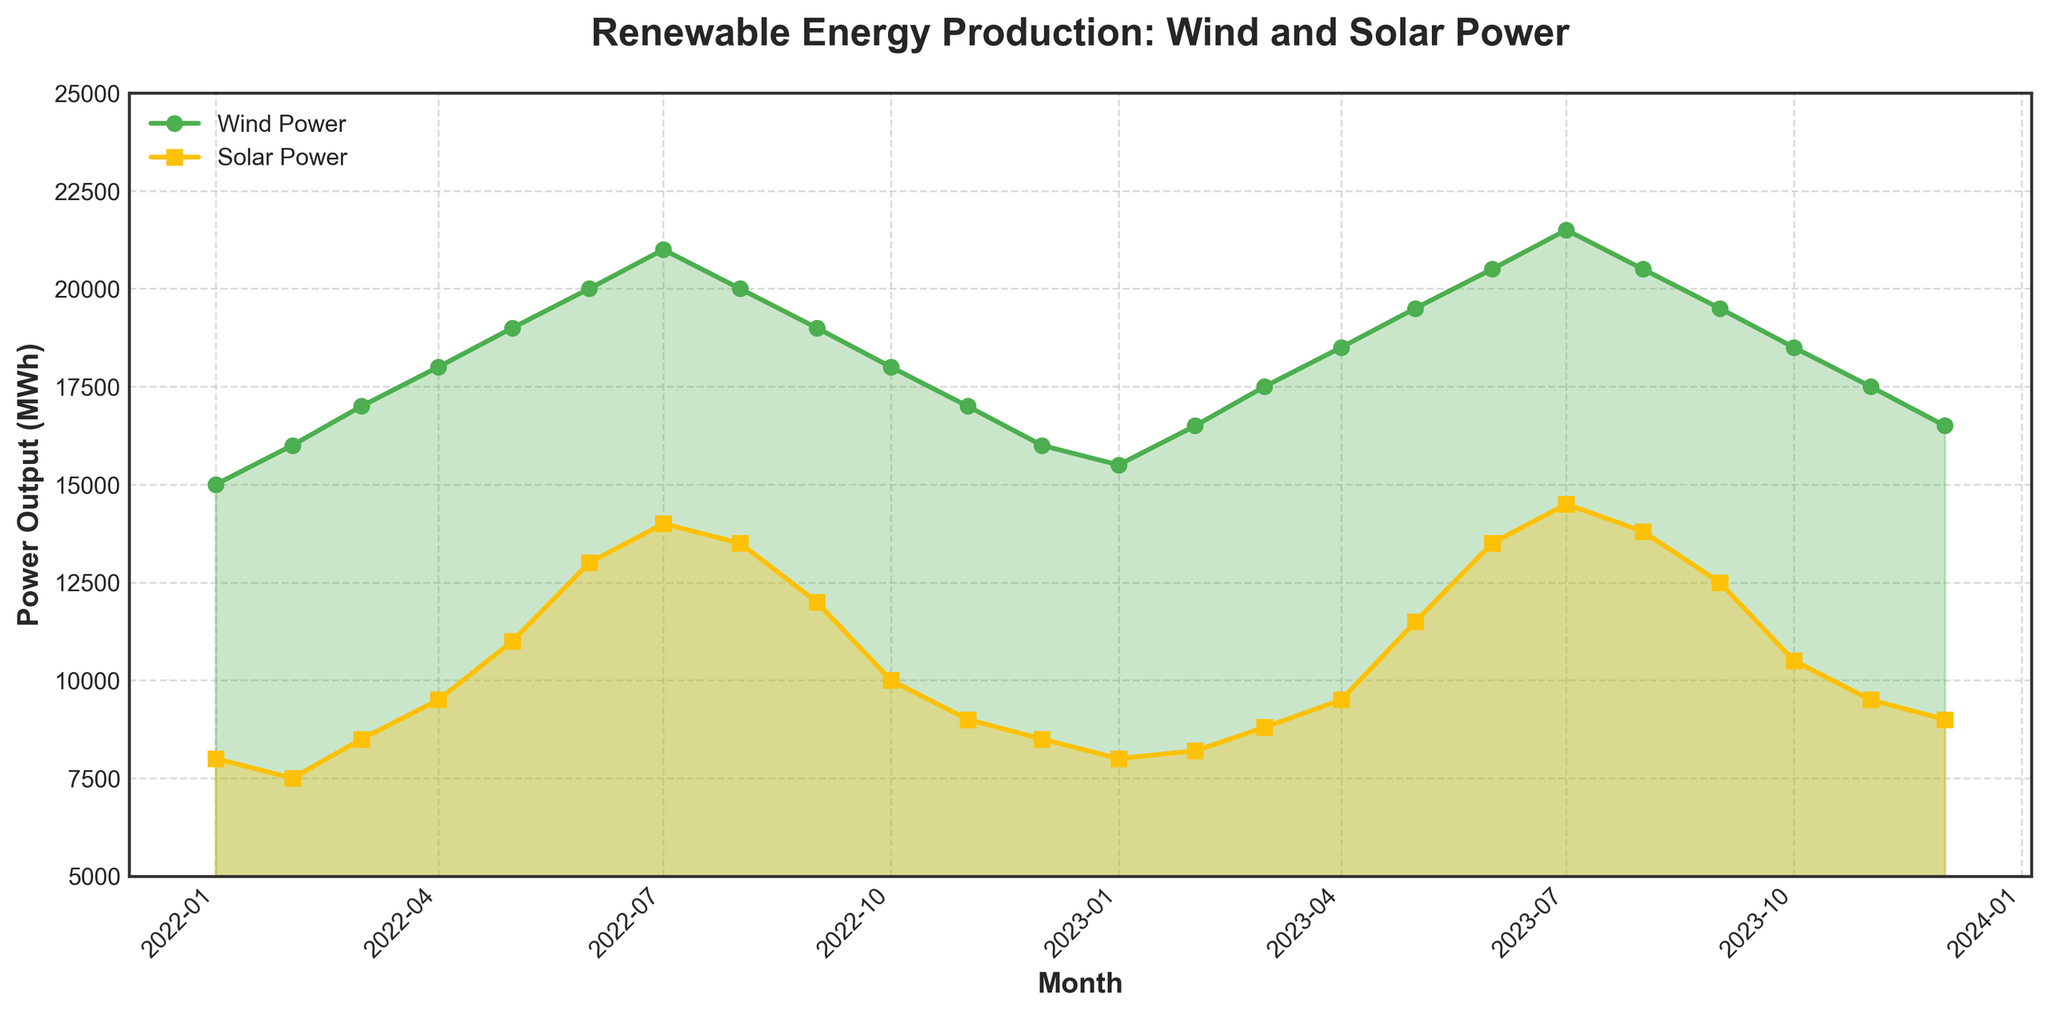What's the title of the figure? The title of the figure is usually displayed prominently at the top. It describes the content of the figure. The title here is "Renewable Energy Production: Wind and Solar Power".
Answer: Renewable Energy Production: Wind and Solar Power What colors represent Wind and Solar Power in the plot? The color for each series is indicated by the line and marker colors in the plot. Wind Power is represented by green and Solar Power is represented by yellow.
Answer: Green and Yellow How does the Wind Power output in 2022-07 compare to that in 2023-07? Looking at the plot, you can see the vertical positions of the data points for July 2022 and July 2023 on the Wind Power series, marked by green circles. Wind Power output in July 2022 is 21,000 MWh and in July 2023 is 21,500 MWh.
Answer: 2023-07 is higher Which month saw the highest Solar Power output? Reviewing the yellow series across the months in the plot indicates that the highest point is in 2023-07 at 14,500 MWh.
Answer: 2023-07 What's the general trend of Wind Power output over the two years? Observing the green series across the span of the plot, you can see that the Wind Power output generally increases over time, with a peak in mid-year and a dip at the start and end of each year.
Answer: Increasing trend What is the wind and solar power output for the first and last months in the dataset? The plot shows:
- January 2022: Wind Power (15,000 MWh), Solar Power (8,000 MWh)
- December 2023: Wind Power (16,500 MWh), Solar Power (9,000 MWh)
Answer: January 2022: 15,000 MWh, 8,000 MWh; December 2023: 16,500 MWh, 9,000 MWh During which month is the difference between Wind Power and Solar Power the largest? To determine this, check the gap between the green and yellow lines across all months. The largest difference appears in July 2022, where Wind Power is 21,000 MWh, and Solar Power is 14,000 MWh, giving a difference of 7,000 MWh.
Answer: 2022-07 What's the average Wind Power output across all months in 2023? To compute the average, sum the Wind Power outputs for each month in 2023: 15,500 + 16,500 + 17,500 + 18,500 + 19,500 + 20,500 + 21,500 + 20,500 + 19,500 + 18,500 + 17,500 + 16,500 = 222,000, then divide by 12.
Answer: 18,500 MWh Describe the seasonal pattern observed in Solar Power production. The yellow series shows a clear seasonal pattern, with Solar Power rising from early in the year, peaking in the summer months (June-July), and declining toward the end of the year. This follows typical solar irradiance patterns.
Answer: Rise in Summer, Decline in Winter In which months do both Wind and Solar Power output have their lowest combined values? To find the lowest combined values, observe the sum of the two outputs (green and yellow lines) for each month. The lowest combined value is in January 2022. Wind Power is 15,000 MWh and Solar Power is 8,000 MWh, totaling 23,000 MWh.
Answer: January 2022 